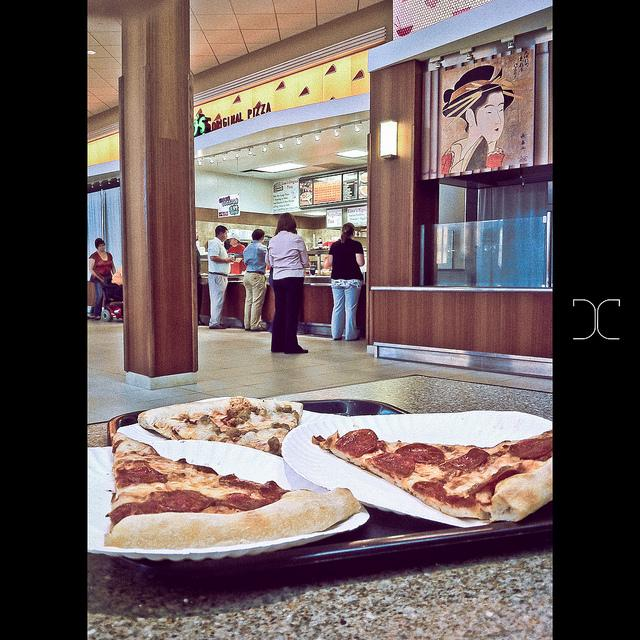Where is this taking place? Please explain your reasoning. food court. There are other businesses next to it 